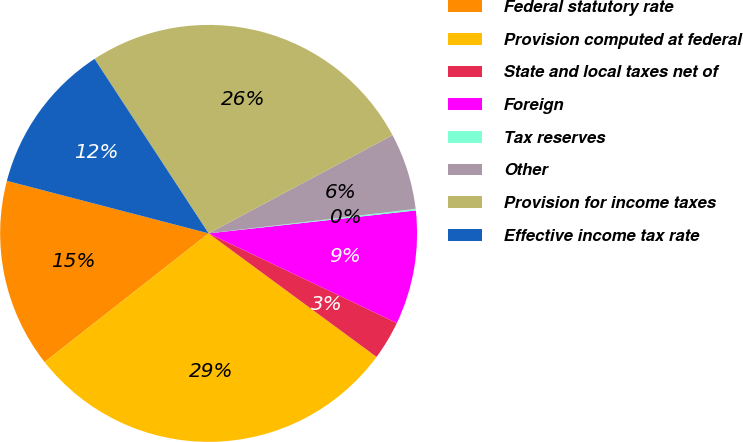<chart> <loc_0><loc_0><loc_500><loc_500><pie_chart><fcel>Federal statutory rate<fcel>Provision computed at federal<fcel>State and local taxes net of<fcel>Foreign<fcel>Tax reserves<fcel>Other<fcel>Provision for income taxes<fcel>Effective income tax rate<nl><fcel>14.64%<fcel>29.32%<fcel>3.02%<fcel>8.83%<fcel>0.12%<fcel>5.93%<fcel>26.41%<fcel>11.73%<nl></chart> 